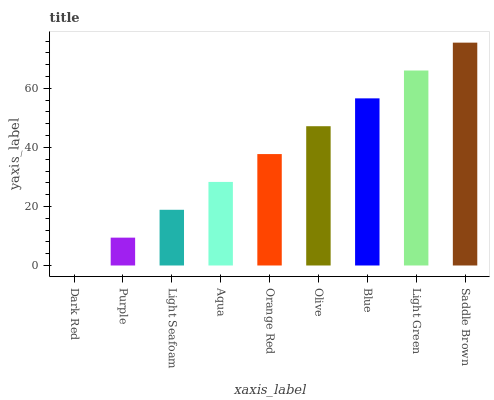Is Dark Red the minimum?
Answer yes or no. Yes. Is Saddle Brown the maximum?
Answer yes or no. Yes. Is Purple the minimum?
Answer yes or no. No. Is Purple the maximum?
Answer yes or no. No. Is Purple greater than Dark Red?
Answer yes or no. Yes. Is Dark Red less than Purple?
Answer yes or no. Yes. Is Dark Red greater than Purple?
Answer yes or no. No. Is Purple less than Dark Red?
Answer yes or no. No. Is Orange Red the high median?
Answer yes or no. Yes. Is Orange Red the low median?
Answer yes or no. Yes. Is Blue the high median?
Answer yes or no. No. Is Saddle Brown the low median?
Answer yes or no. No. 